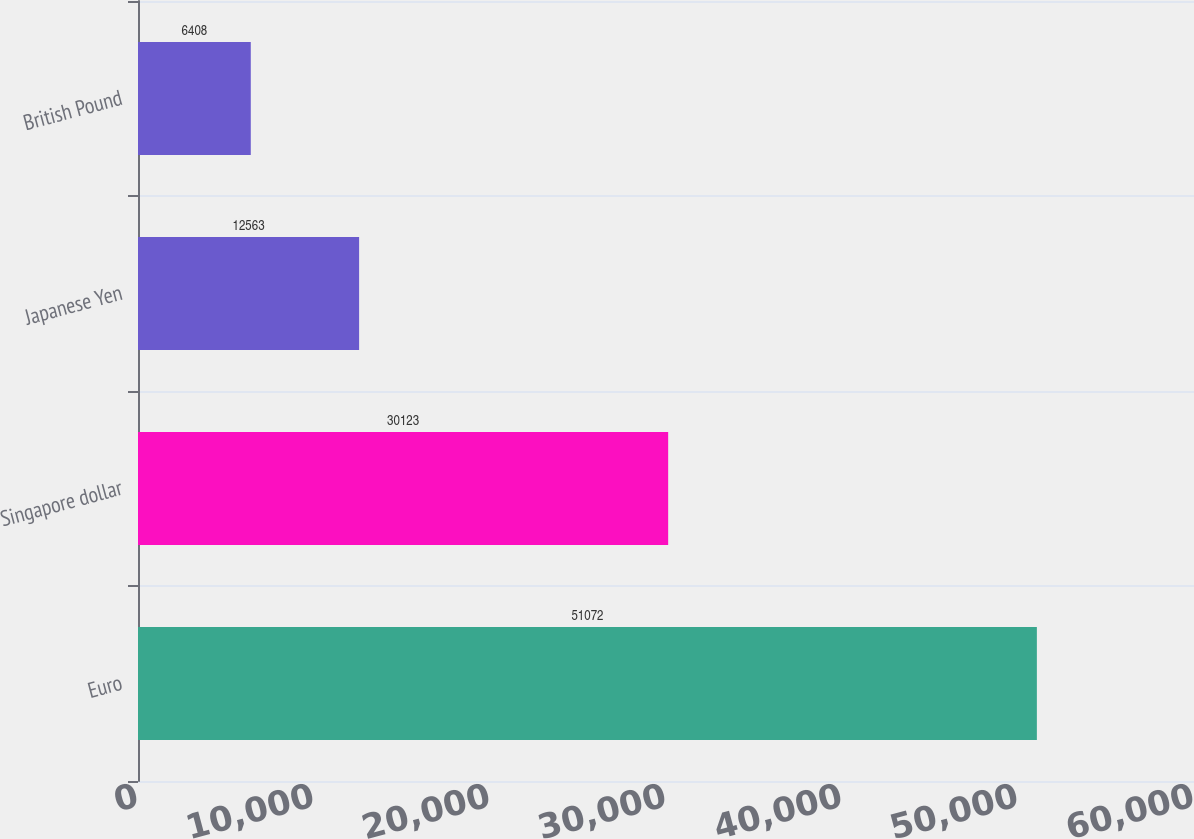Convert chart. <chart><loc_0><loc_0><loc_500><loc_500><bar_chart><fcel>Euro<fcel>Singapore dollar<fcel>Japanese Yen<fcel>British Pound<nl><fcel>51072<fcel>30123<fcel>12563<fcel>6408<nl></chart> 